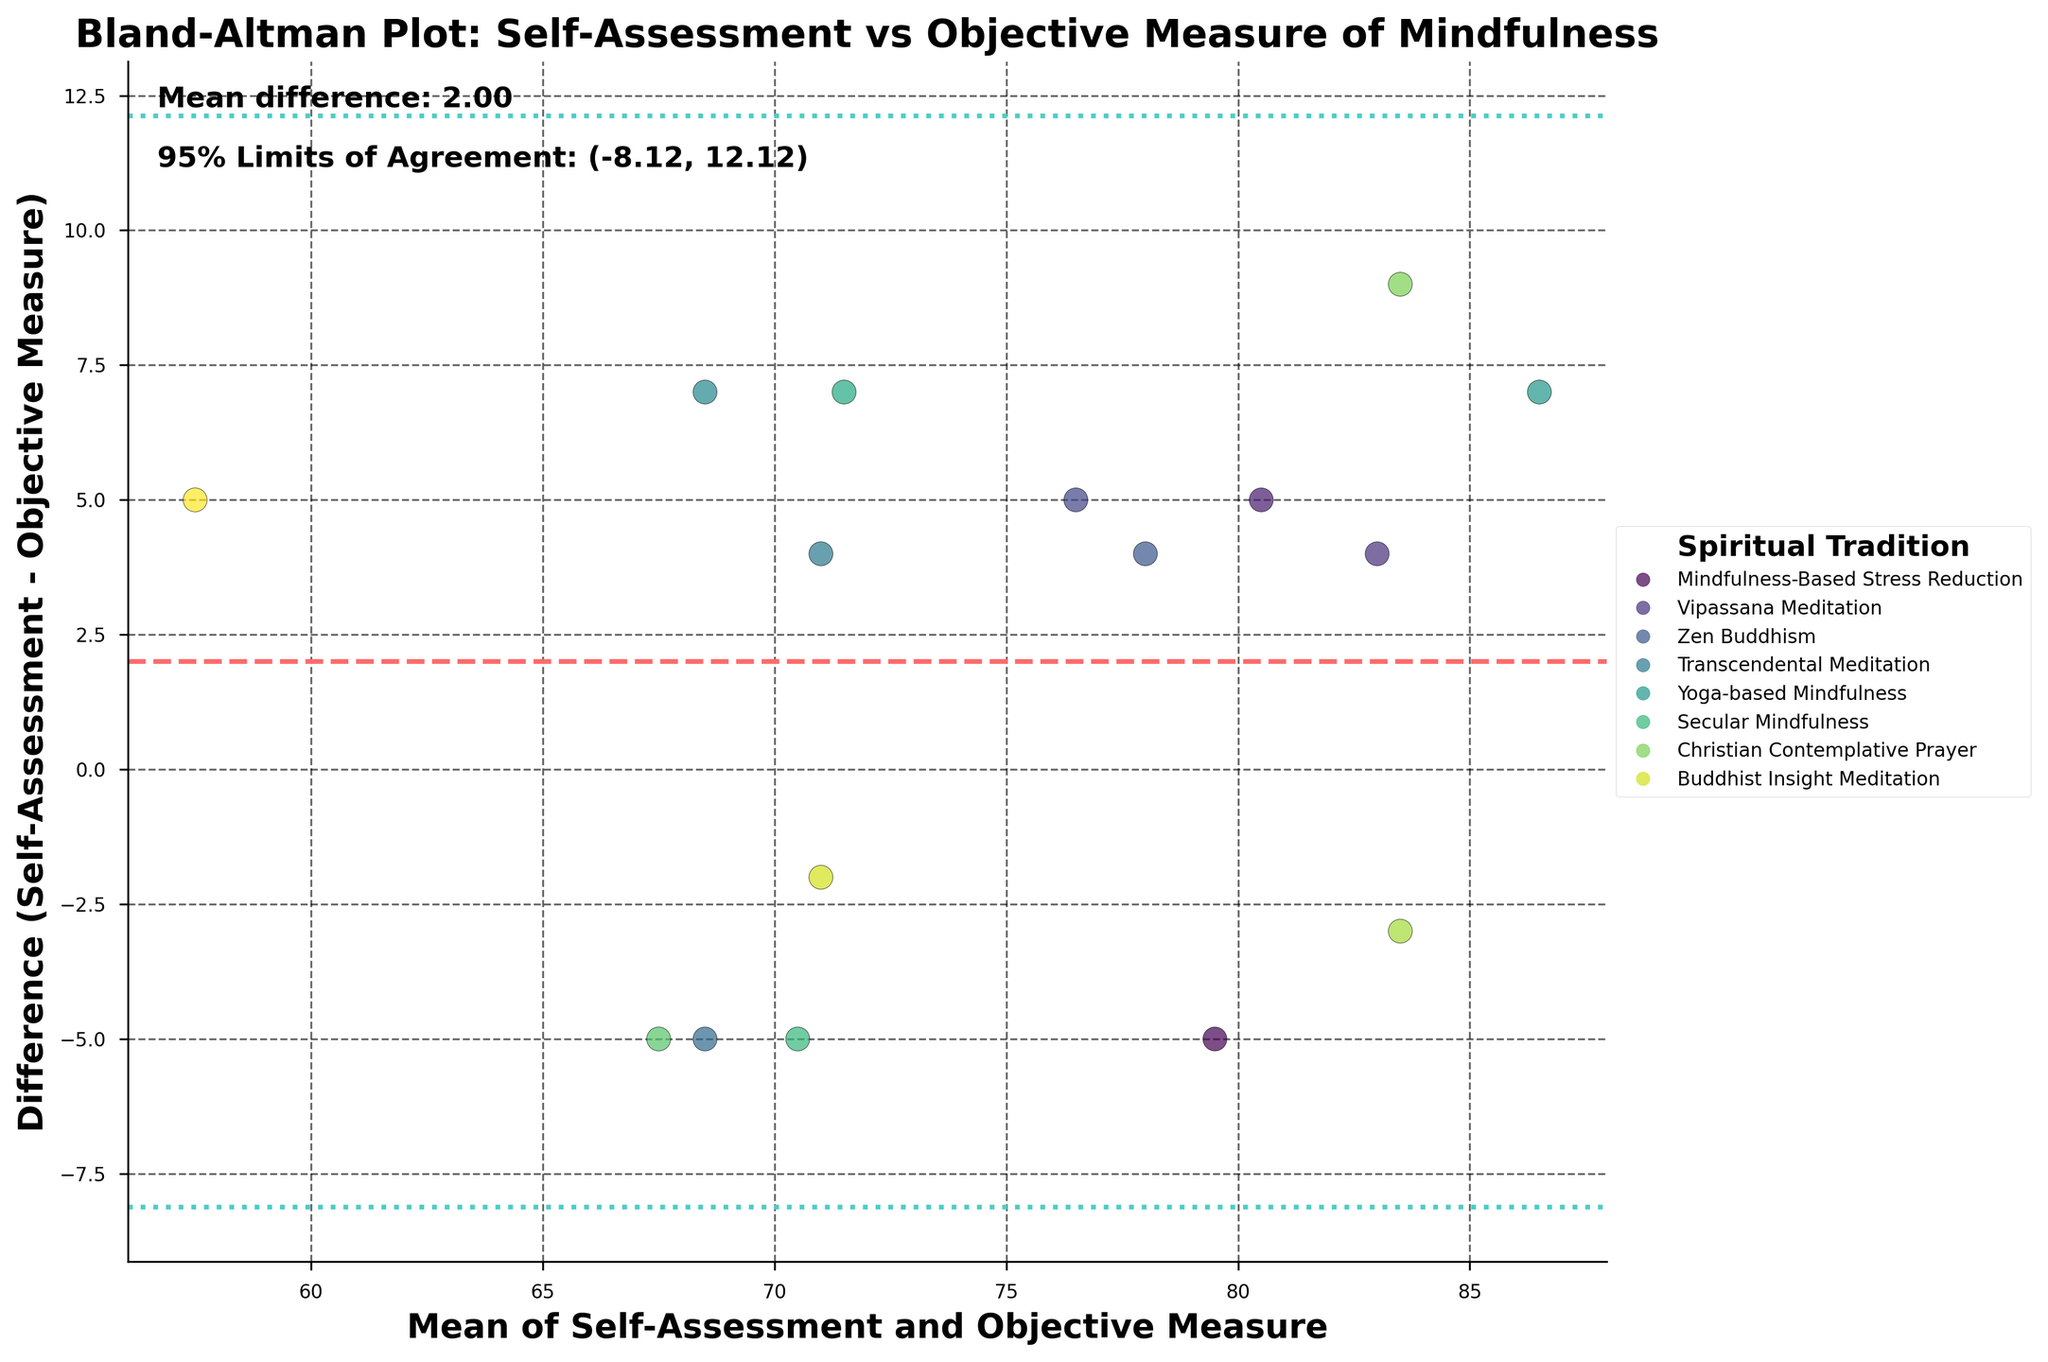What is the title of the figure? The title of the figure is located at the top, often in a larger and bold font, which provides a brief description of what the figure is about.
Answer: Bland-Altman Plot: Self-Assessment vs Objective Measure of Mindfulness What are the axes labeled with on the plot? The labels on the axes describe what the x-axis and y-axis represent, found along each axis in bold text.
Answer: The x-axis is labeled 'Mean of Self-Assessment and Objective Measure', and the y-axis is labeled 'Difference (Self-Assessment - Objective Measure)' How many data points are in the plot? Each data point represents one subject; counting all the individual points on the scatter plot gives the total number of data points.
Answer: 16 What does the color of each point represent? The points are colored based on categories, often explained in the plot legend found to the right of the plot.
Answer: Spiritual Tradition What is the mean difference between self-assessment and objective measures? The horizontal dashed line on the plot indicates the mean difference, annotated in the figure's text.
Answer: 3.00 What are the 95% limits of agreement? The two dotted lines above and below the mean difference indicate the 95% limits of agreement, annotated in the figure as a range.
Answer: (-6.18, 12.18) Which spiritual tradition has the largest positive difference between self-assessment and objective measures? Look for the highest point above the mean difference line and refer to the color or legend to identify the spiritual tradition.
Answer: Yoga-based Mindfulness Which spiritual tradition has the largest negative difference between self-assessment and objective measures? Look for the lowest point below the mean difference line and refer to the color or legend to identify the spiritual tradition.
Answer: Mindfulness-Based Cognitive Therapy How many traditions have more than 3 points above the mean difference line? Count the points above the mean difference line for each unique tradition by identifying the colors associated with each tradition.
Answer: 3 Which tradition has the smallest average difference between self-assessment and objective measures? Find the tradition whose points are closest to the mean difference line both above and below. Calculate the average of these differences visually.
Answer: Secular Mindfulness 